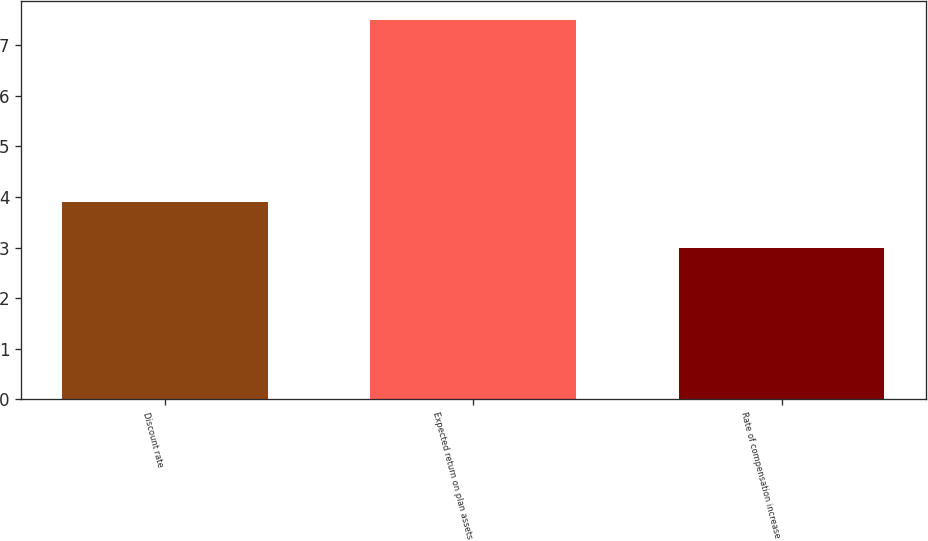<chart> <loc_0><loc_0><loc_500><loc_500><bar_chart><fcel>Discount rate<fcel>Expected return on plan assets<fcel>Rate of compensation increase<nl><fcel>3.9<fcel>7.5<fcel>3<nl></chart> 